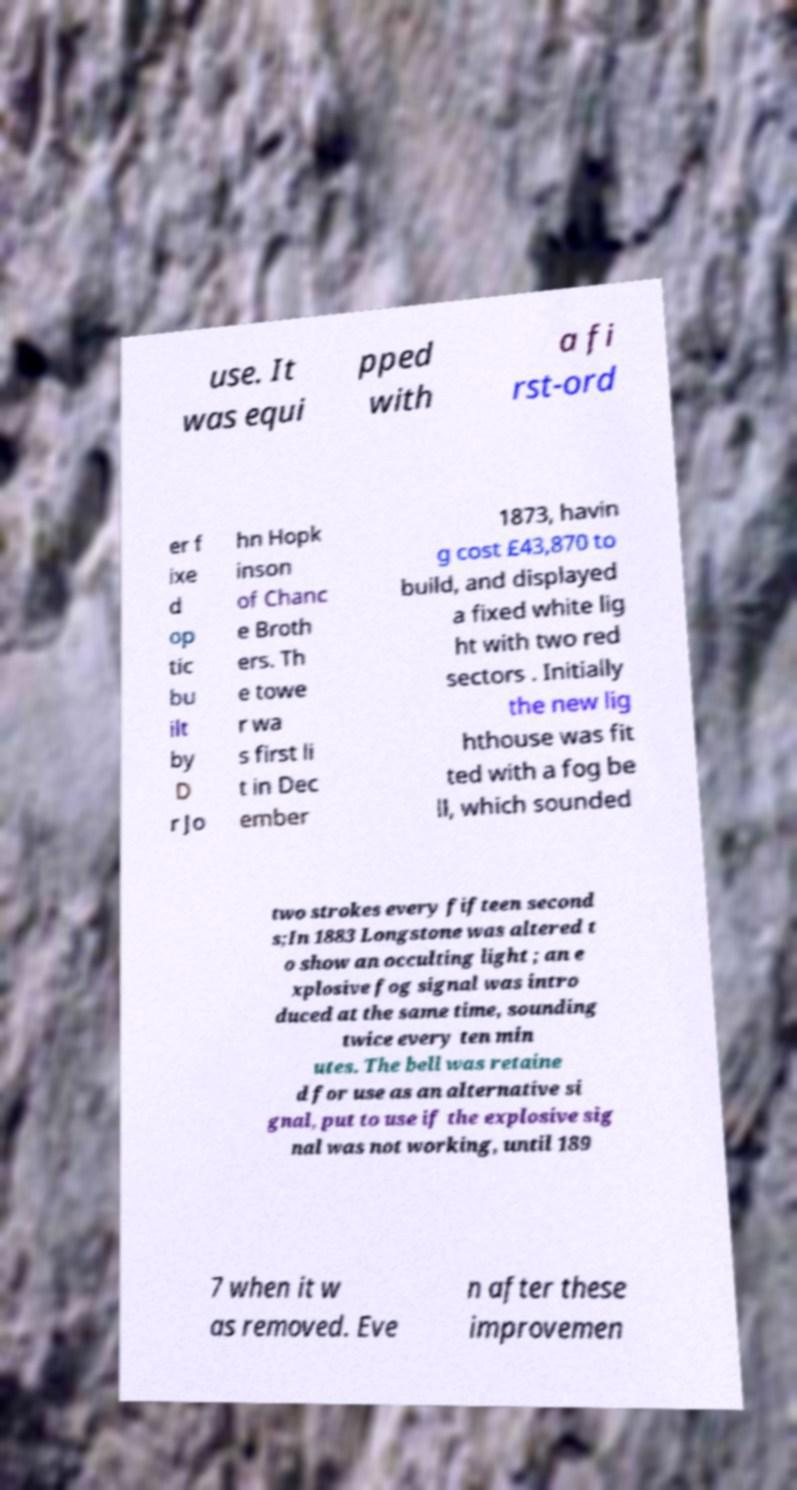Could you extract and type out the text from this image? use. It was equi pped with a fi rst-ord er f ixe d op tic bu ilt by D r Jo hn Hopk inson of Chanc e Broth ers. Th e towe r wa s first li t in Dec ember 1873, havin g cost £43,870 to build, and displayed a fixed white lig ht with two red sectors . Initially the new lig hthouse was fit ted with a fog be ll, which sounded two strokes every fifteen second s;In 1883 Longstone was altered t o show an occulting light ; an e xplosive fog signal was intro duced at the same time, sounding twice every ten min utes. The bell was retaine d for use as an alternative si gnal, put to use if the explosive sig nal was not working, until 189 7 when it w as removed. Eve n after these improvemen 